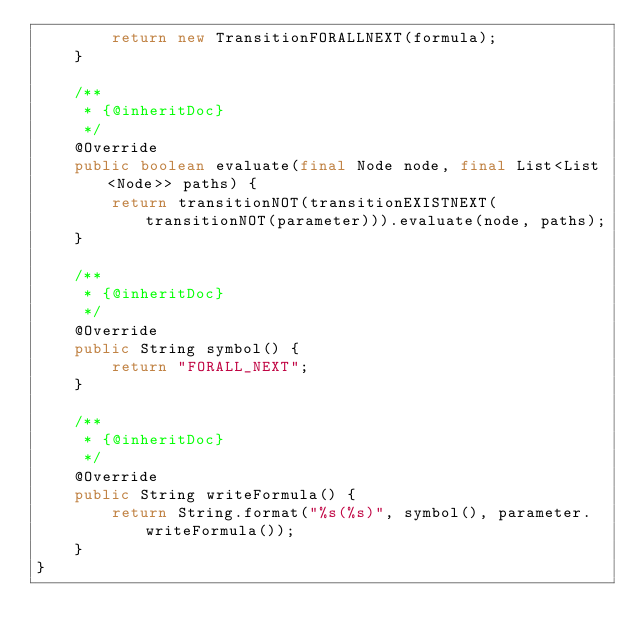<code> <loc_0><loc_0><loc_500><loc_500><_Java_>        return new TransitionFORALLNEXT(formula);
    }

    /**
     * {@inheritDoc}
     */
    @Override
    public boolean evaluate(final Node node, final List<List<Node>> paths) {
        return transitionNOT(transitionEXISTNEXT(transitionNOT(parameter))).evaluate(node, paths);
    }

    /**
     * {@inheritDoc}
     */
    @Override
    public String symbol() {
        return "FORALL_NEXT";
    }

    /**
     * {@inheritDoc}
     */
    @Override
    public String writeFormula() {
        return String.format("%s(%s)", symbol(), parameter.writeFormula());
    }
}
</code> 